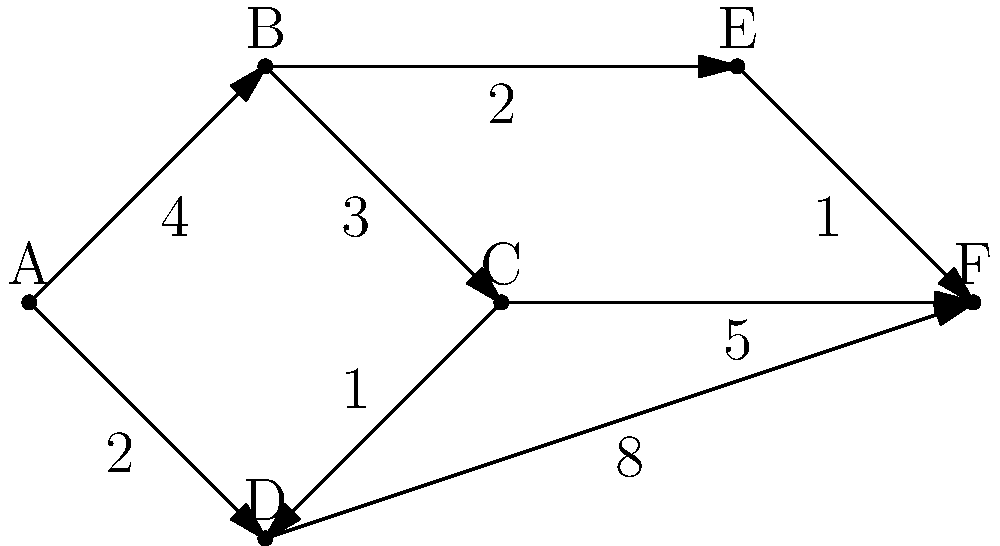As a web development instructor, you're teaching a lesson on graph algorithms and their applications in routing for web applications. Given the weighted graph above, what is the shortest path from node A to node F, and what is its total weight? Explain how this concept relates to optimizing network requests in web development. To find the shortest path from A to F, we'll use Dijkstra's algorithm, which is commonly used in web development for optimizing network requests and routing. Here's the step-by-step process:

1. Initialize distances: A(0), B(∞), C(∞), D(∞), E(∞), F(∞)
2. Start from A:
   - Update B: min(∞, 0+4) = 4
   - Update D: min(∞, 0+2) = 2
3. Move to D (nearest unvisited node):
   - Update C: min(∞, 2+1) = 3
   - Update F: min(∞, 2+8) = 10
4. Move to B:
   - Update C: min(3, 4+3) = 3 (no change)
   - Update E: min(∞, 4+2) = 6
5. Move to C:
   - Update F: min(10, 3+5) = 8
6. Move to E:
   - Update F: min(8, 6+1) = 7

The shortest path is A → D → C → E → F with a total weight of 7.

In web development, this concept relates to optimizing network requests by:
1. Minimizing the number of API calls
2. Choosing the most efficient data transfer routes
3. Implementing efficient caching strategies
4. Optimizing database queries and joins

Understanding graph algorithms helps in designing efficient routing systems for single-page applications (SPAs) and optimizing data flow in microservices architectures.
Answer: A → D → C → E → F, weight: 7 